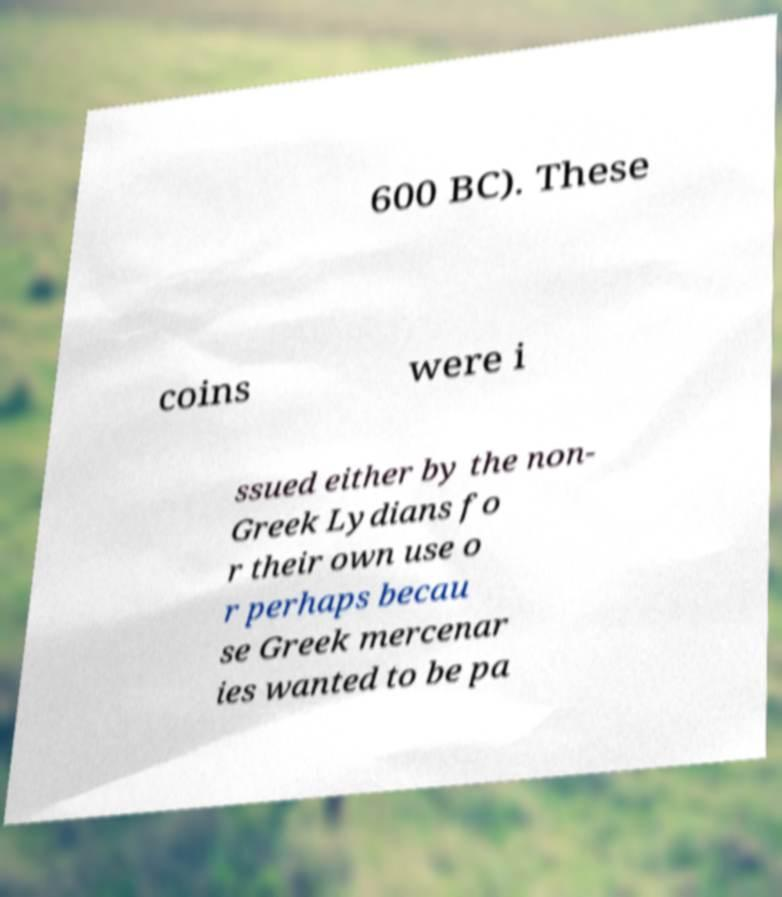There's text embedded in this image that I need extracted. Can you transcribe it verbatim? 600 BC). These coins were i ssued either by the non- Greek Lydians fo r their own use o r perhaps becau se Greek mercenar ies wanted to be pa 